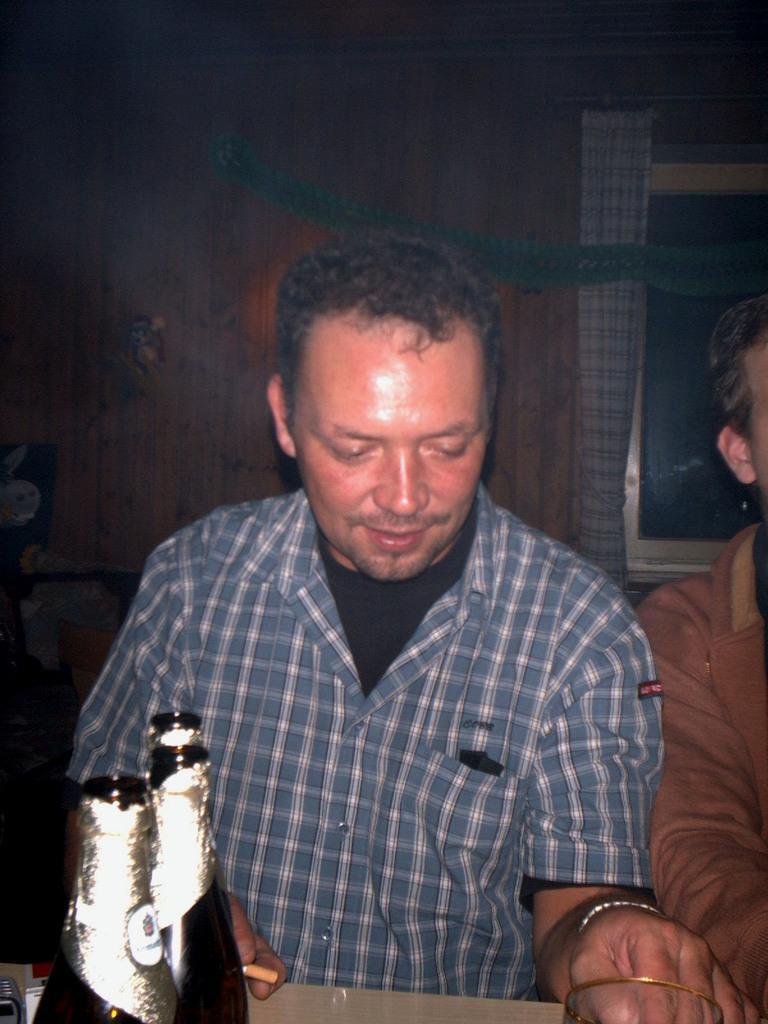Could you give a brief overview of what you see in this image? Here we can see a man. This is table. On the table there are bottles, and a glass. On the background there is a wall and this is window. And there is a curtain. 